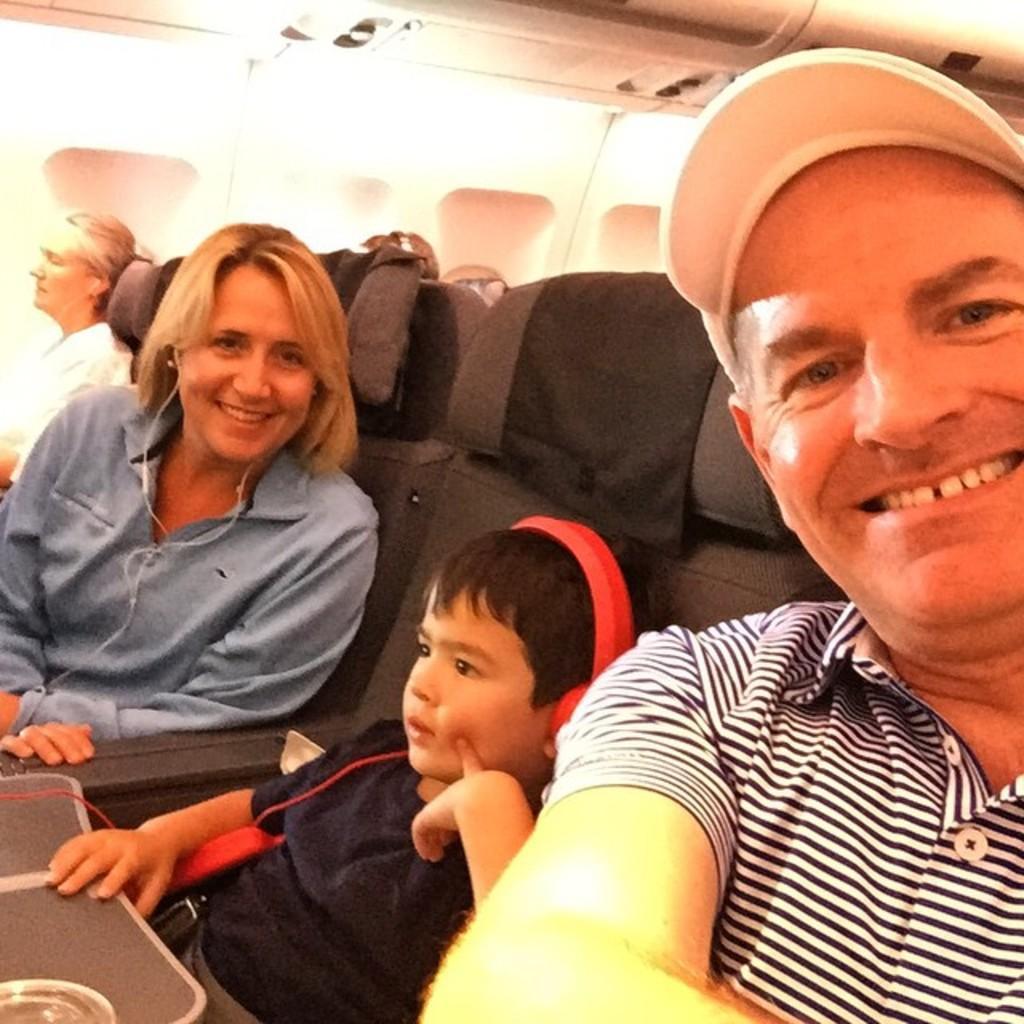Describe this image in one or two sentences. In this image there is a man, woman and a child has seated in a plane. 